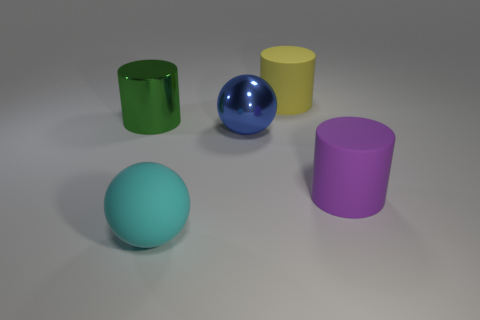Is there any other thing that has the same size as the green shiny object?
Provide a short and direct response. Yes. What number of other things are there of the same shape as the large blue object?
Give a very brief answer. 1. What color is the rubber sphere that is the same size as the green cylinder?
Make the answer very short. Cyan. What is the color of the rubber thing to the right of the big yellow thing?
Give a very brief answer. Purple. Is there a cyan sphere that is in front of the large cylinder to the left of the big cyan matte thing?
Your answer should be compact. Yes. There is a blue metallic thing; is its shape the same as the rubber object that is on the right side of the large yellow thing?
Offer a very short reply. No. There is a cylinder that is in front of the big yellow object and right of the green cylinder; how big is it?
Make the answer very short. Large. Is there a tiny blue cube that has the same material as the yellow object?
Your response must be concise. No. What is the material of the big sphere that is behind the cyan rubber ball left of the yellow rubber thing?
Provide a short and direct response. Metal. What size is the cyan thing that is the same material as the large purple object?
Provide a succinct answer. Large. 